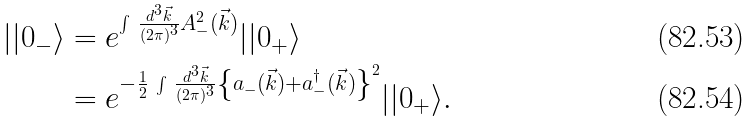Convert formula to latex. <formula><loc_0><loc_0><loc_500><loc_500>| | 0 _ { - } \rangle & = e ^ { \int \, \frac { d ^ { 3 } \vec { k } } { ( 2 \pi ) ^ { 3 } } A _ { - } ^ { 2 } ( \vec { k } ) } | | 0 _ { + } \rangle \\ & = e ^ { - \frac { 1 } { 2 } \, \int \, \frac { d ^ { 3 } \vec { k } } { ( 2 \pi ) ^ { 3 } } \left \{ a _ { - } ( \vec { k } ) + a _ { - } ^ { \dagger } ( \vec { k } ) \right \} ^ { 2 } } | | 0 _ { + } \rangle .</formula> 